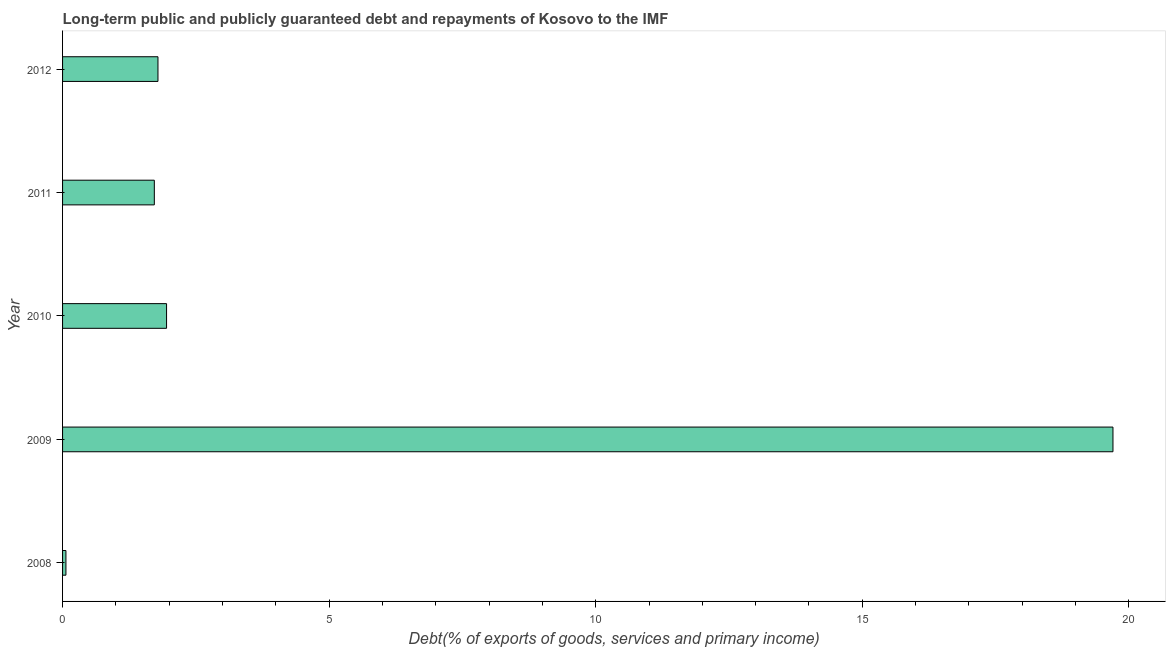Does the graph contain any zero values?
Make the answer very short. No. Does the graph contain grids?
Your answer should be compact. No. What is the title of the graph?
Keep it short and to the point. Long-term public and publicly guaranteed debt and repayments of Kosovo to the IMF. What is the label or title of the X-axis?
Your response must be concise. Debt(% of exports of goods, services and primary income). What is the debt service in 2009?
Your answer should be compact. 19.7. Across all years, what is the maximum debt service?
Provide a short and direct response. 19.7. Across all years, what is the minimum debt service?
Ensure brevity in your answer.  0.06. In which year was the debt service maximum?
Ensure brevity in your answer.  2009. What is the sum of the debt service?
Offer a terse response. 25.23. What is the difference between the debt service in 2011 and 2012?
Ensure brevity in your answer.  -0.07. What is the average debt service per year?
Make the answer very short. 5.04. What is the median debt service?
Keep it short and to the point. 1.79. What is the ratio of the debt service in 2008 to that in 2011?
Offer a terse response. 0.04. Is the debt service in 2009 less than that in 2011?
Your answer should be very brief. No. Is the difference between the debt service in 2009 and 2012 greater than the difference between any two years?
Keep it short and to the point. No. What is the difference between the highest and the second highest debt service?
Make the answer very short. 17.75. Is the sum of the debt service in 2008 and 2011 greater than the maximum debt service across all years?
Offer a terse response. No. What is the difference between the highest and the lowest debt service?
Provide a succinct answer. 19.64. What is the Debt(% of exports of goods, services and primary income) of 2008?
Give a very brief answer. 0.06. What is the Debt(% of exports of goods, services and primary income) of 2009?
Provide a succinct answer. 19.7. What is the Debt(% of exports of goods, services and primary income) in 2010?
Offer a terse response. 1.95. What is the Debt(% of exports of goods, services and primary income) in 2011?
Offer a very short reply. 1.72. What is the Debt(% of exports of goods, services and primary income) in 2012?
Make the answer very short. 1.79. What is the difference between the Debt(% of exports of goods, services and primary income) in 2008 and 2009?
Ensure brevity in your answer.  -19.64. What is the difference between the Debt(% of exports of goods, services and primary income) in 2008 and 2010?
Offer a very short reply. -1.89. What is the difference between the Debt(% of exports of goods, services and primary income) in 2008 and 2011?
Offer a very short reply. -1.66. What is the difference between the Debt(% of exports of goods, services and primary income) in 2008 and 2012?
Give a very brief answer. -1.73. What is the difference between the Debt(% of exports of goods, services and primary income) in 2009 and 2010?
Keep it short and to the point. 17.75. What is the difference between the Debt(% of exports of goods, services and primary income) in 2009 and 2011?
Offer a very short reply. 17.98. What is the difference between the Debt(% of exports of goods, services and primary income) in 2009 and 2012?
Provide a short and direct response. 17.91. What is the difference between the Debt(% of exports of goods, services and primary income) in 2010 and 2011?
Offer a terse response. 0.23. What is the difference between the Debt(% of exports of goods, services and primary income) in 2010 and 2012?
Give a very brief answer. 0.16. What is the difference between the Debt(% of exports of goods, services and primary income) in 2011 and 2012?
Your answer should be very brief. -0.07. What is the ratio of the Debt(% of exports of goods, services and primary income) in 2008 to that in 2009?
Ensure brevity in your answer.  0. What is the ratio of the Debt(% of exports of goods, services and primary income) in 2008 to that in 2010?
Make the answer very short. 0.03. What is the ratio of the Debt(% of exports of goods, services and primary income) in 2008 to that in 2011?
Your response must be concise. 0.04. What is the ratio of the Debt(% of exports of goods, services and primary income) in 2008 to that in 2012?
Offer a terse response. 0.04. What is the ratio of the Debt(% of exports of goods, services and primary income) in 2009 to that in 2011?
Give a very brief answer. 11.45. What is the ratio of the Debt(% of exports of goods, services and primary income) in 2009 to that in 2012?
Your response must be concise. 11.01. What is the ratio of the Debt(% of exports of goods, services and primary income) in 2010 to that in 2011?
Provide a short and direct response. 1.13. What is the ratio of the Debt(% of exports of goods, services and primary income) in 2010 to that in 2012?
Your answer should be compact. 1.09. 